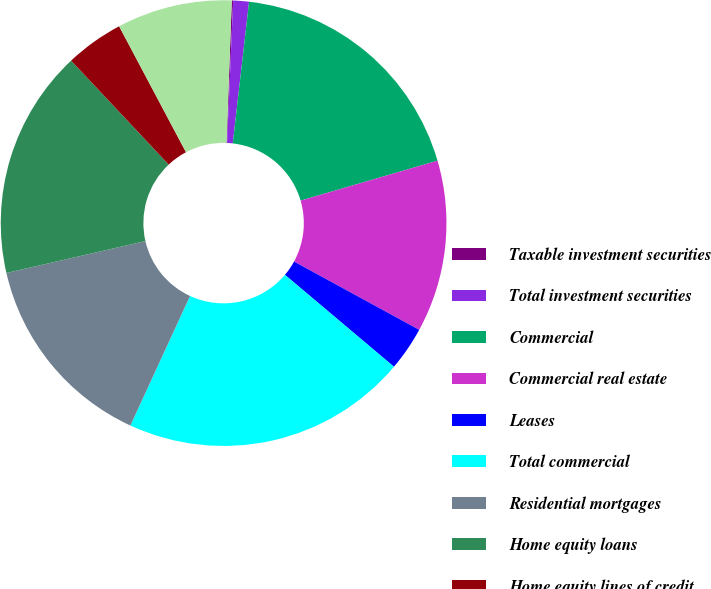<chart> <loc_0><loc_0><loc_500><loc_500><pie_chart><fcel>Taxable investment securities<fcel>Total investment securities<fcel>Commercial<fcel>Commercial real estate<fcel>Leases<fcel>Total commercial<fcel>Residential mortgages<fcel>Home equity loans<fcel>Home equity lines of credit<fcel>Home equity loans serviced by<nl><fcel>0.1%<fcel>1.14%<fcel>18.66%<fcel>12.47%<fcel>3.2%<fcel>20.72%<fcel>14.54%<fcel>16.6%<fcel>4.23%<fcel>8.35%<nl></chart> 